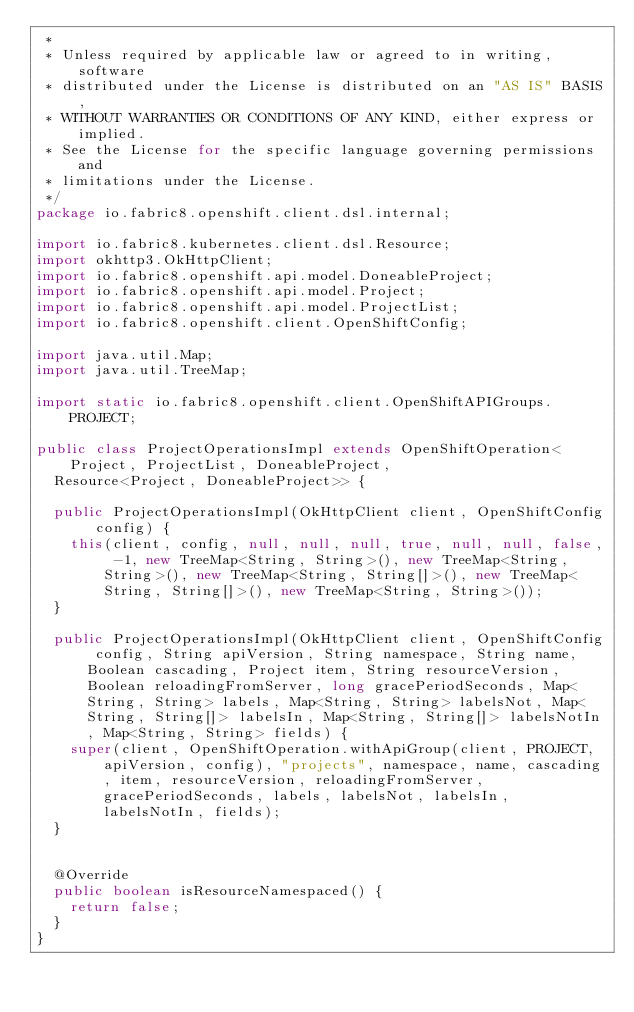Convert code to text. <code><loc_0><loc_0><loc_500><loc_500><_Java_> *
 * Unless required by applicable law or agreed to in writing, software
 * distributed under the License is distributed on an "AS IS" BASIS,
 * WITHOUT WARRANTIES OR CONDITIONS OF ANY KIND, either express or implied.
 * See the License for the specific language governing permissions and
 * limitations under the License.
 */
package io.fabric8.openshift.client.dsl.internal;

import io.fabric8.kubernetes.client.dsl.Resource;
import okhttp3.OkHttpClient;
import io.fabric8.openshift.api.model.DoneableProject;
import io.fabric8.openshift.api.model.Project;
import io.fabric8.openshift.api.model.ProjectList;
import io.fabric8.openshift.client.OpenShiftConfig;

import java.util.Map;
import java.util.TreeMap;

import static io.fabric8.openshift.client.OpenShiftAPIGroups.PROJECT;

public class ProjectOperationsImpl extends OpenShiftOperation<Project, ProjectList, DoneableProject,
  Resource<Project, DoneableProject>> {

  public ProjectOperationsImpl(OkHttpClient client, OpenShiftConfig config) {
    this(client, config, null, null, null, true, null, null, false, -1, new TreeMap<String, String>(), new TreeMap<String, String>(), new TreeMap<String, String[]>(), new TreeMap<String, String[]>(), new TreeMap<String, String>());
  }

  public ProjectOperationsImpl(OkHttpClient client, OpenShiftConfig config, String apiVersion, String namespace, String name, Boolean cascading, Project item, String resourceVersion, Boolean reloadingFromServer, long gracePeriodSeconds, Map<String, String> labels, Map<String, String> labelsNot, Map<String, String[]> labelsIn, Map<String, String[]> labelsNotIn, Map<String, String> fields) {
    super(client, OpenShiftOperation.withApiGroup(client, PROJECT, apiVersion, config), "projects", namespace, name, cascading, item, resourceVersion, reloadingFromServer, gracePeriodSeconds, labels, labelsNot, labelsIn, labelsNotIn, fields);
  }


  @Override
  public boolean isResourceNamespaced() {
    return false;
  }
}
</code> 